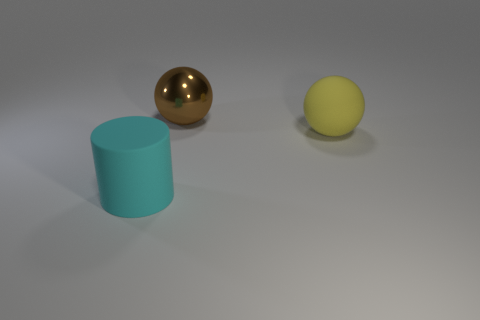The large object that is the same material as the big cylinder is what color?
Your response must be concise. Yellow. What number of big cyan things are made of the same material as the large yellow object?
Your response must be concise. 1. Is the number of yellow objects on the left side of the cyan cylinder less than the number of yellow spheres?
Provide a succinct answer. Yes. Are there any large rubber things behind the rubber object in front of the yellow rubber object?
Your response must be concise. Yes. Are there any other things that are the same shape as the cyan thing?
Your answer should be very brief. No. The object that is in front of the big matte object that is to the right of the big matte thing in front of the large yellow thing is made of what material?
Give a very brief answer. Rubber. Are there an equal number of large cylinders that are behind the large metal ball and yellow cylinders?
Provide a succinct answer. Yes. Are there any other things that have the same size as the brown metallic sphere?
Your response must be concise. Yes. How many objects are yellow balls or big blue matte things?
Your answer should be compact. 1. What shape is the big cyan object that is made of the same material as the yellow ball?
Keep it short and to the point. Cylinder. 